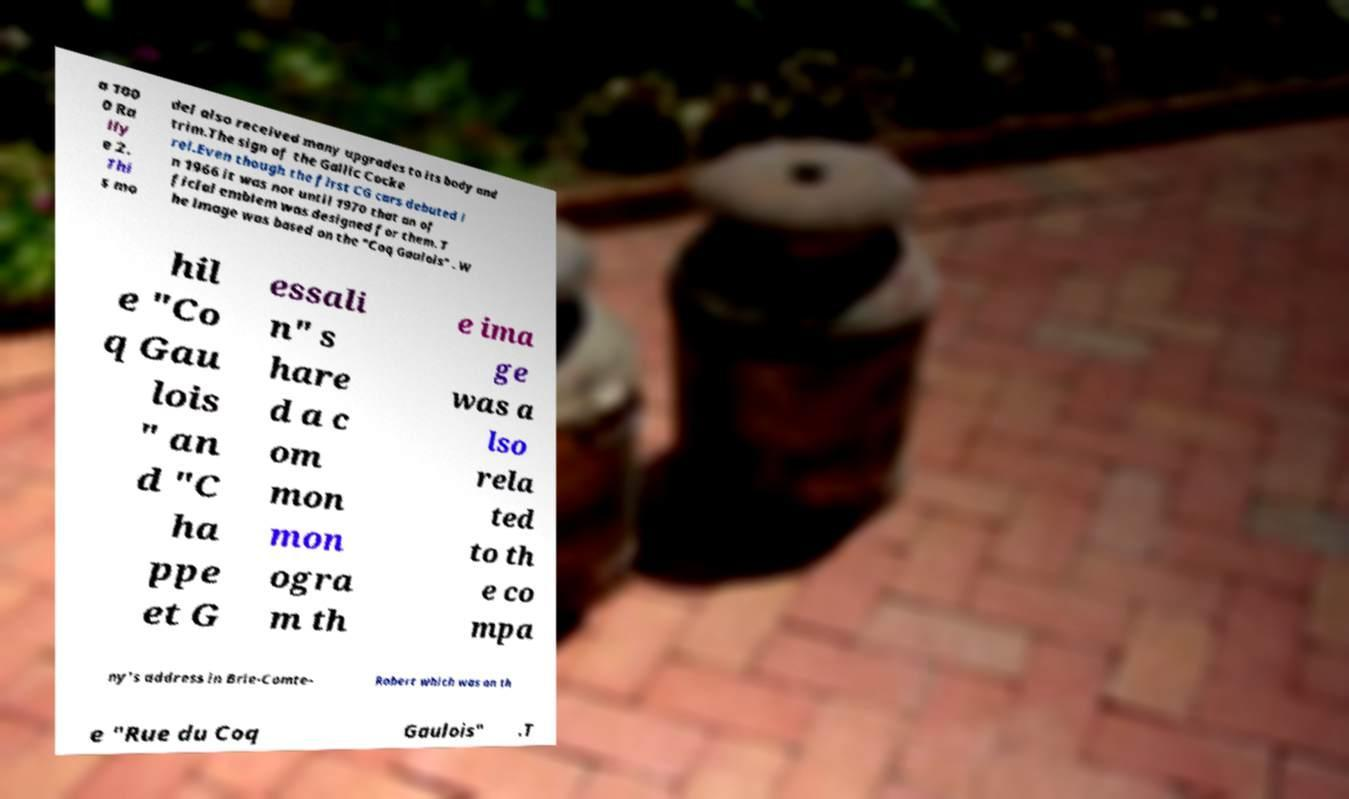Please read and relay the text visible in this image. What does it say? a 100 0 Ra lly e 2. Thi s mo del also received many upgrades to its body and trim.The sign of the Gallic Cocke rel.Even though the first CG cars debuted i n 1966 it was not until 1970 that an of ficial emblem was designed for them. T he image was based on the "Coq Gaulois" . W hil e "Co q Gau lois " an d "C ha ppe et G essali n" s hare d a c om mon mon ogra m th e ima ge was a lso rela ted to th e co mpa ny's address in Brie-Comte- Robert which was on th e "Rue du Coq Gaulois" .T 